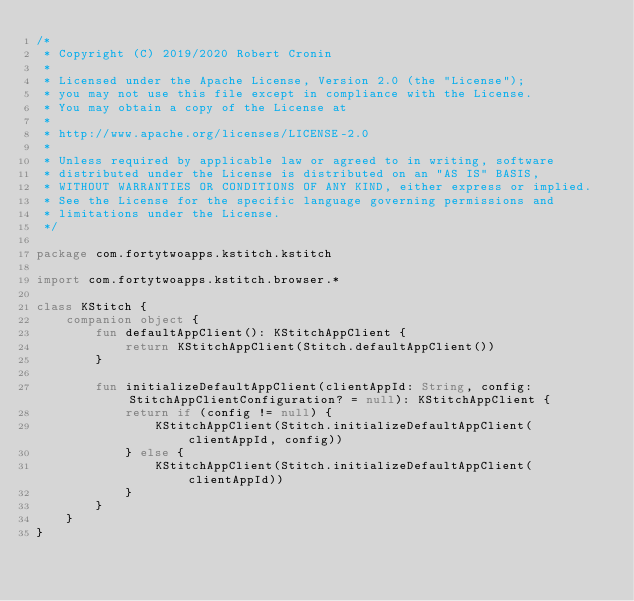<code> <loc_0><loc_0><loc_500><loc_500><_Kotlin_>/*
 * Copyright (C) 2019/2020 Robert Cronin
 *
 * Licensed under the Apache License, Version 2.0 (the "License");
 * you may not use this file except in compliance with the License.
 * You may obtain a copy of the License at
 *
 * http://www.apache.org/licenses/LICENSE-2.0
 *
 * Unless required by applicable law or agreed to in writing, software
 * distributed under the License is distributed on an "AS IS" BASIS,
 * WITHOUT WARRANTIES OR CONDITIONS OF ANY KIND, either express or implied.
 * See the License for the specific language governing permissions and
 * limitations under the License.
 */

package com.fortytwoapps.kstitch.kstitch

import com.fortytwoapps.kstitch.browser.*

class KStitch {
    companion object {
        fun defaultAppClient(): KStitchAppClient {
            return KStitchAppClient(Stitch.defaultAppClient())
        }

        fun initializeDefaultAppClient(clientAppId: String, config: StitchAppClientConfiguration? = null): KStitchAppClient {
            return if (config != null) {
                KStitchAppClient(Stitch.initializeDefaultAppClient(clientAppId, config))
            } else {
                KStitchAppClient(Stitch.initializeDefaultAppClient(clientAppId))
            }
        }
    }
}

</code> 